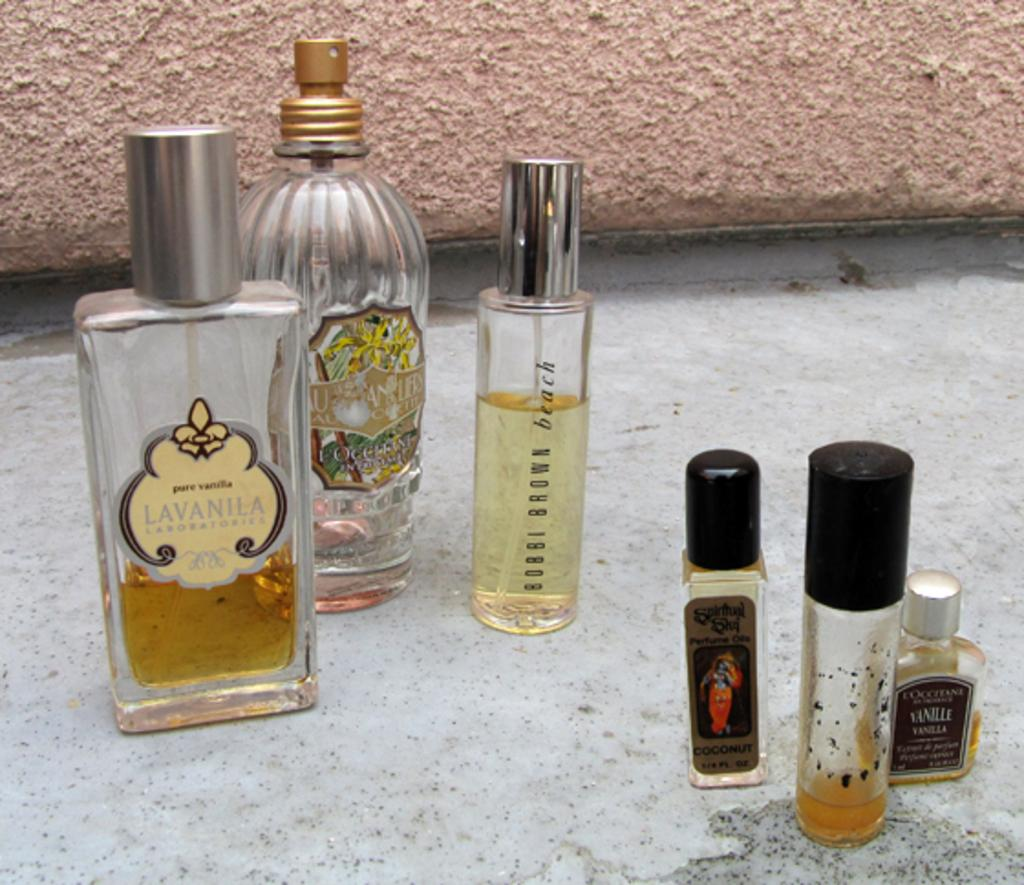<image>
Give a short and clear explanation of the subsequent image. Bobbi Brown beach sits between five other perfumes. 